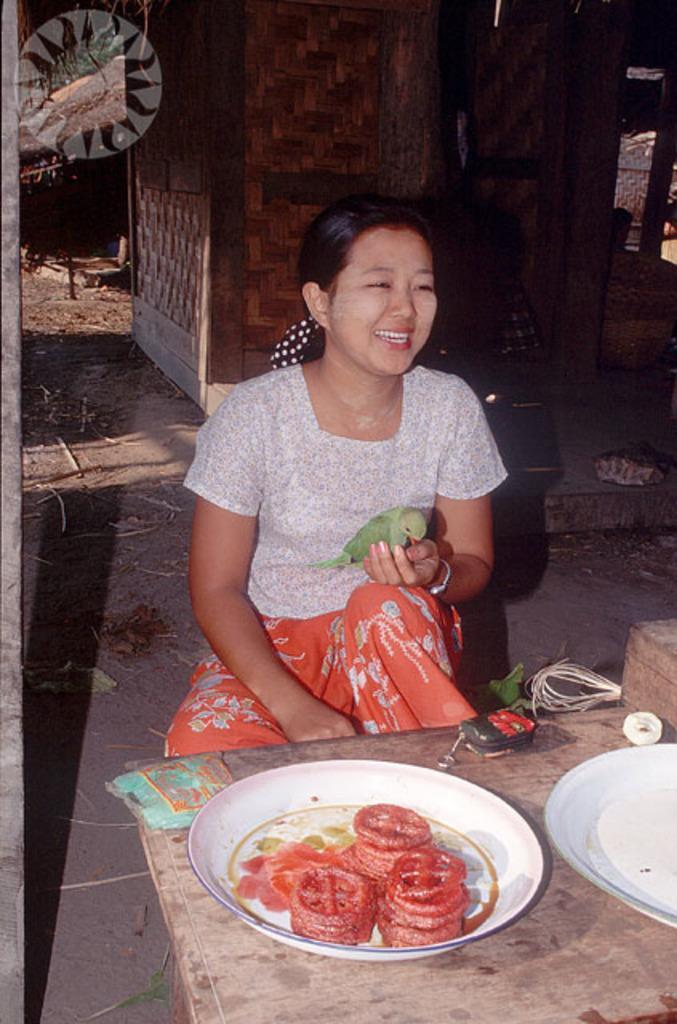Please provide a concise description of this image. There is a lady sitting and holding a parrot. In front of her there is a wooden platform. On that there are plates. On the plate there are some snacks. In the back there is a wooden wall. Also there is a watermark in the left top corner. 